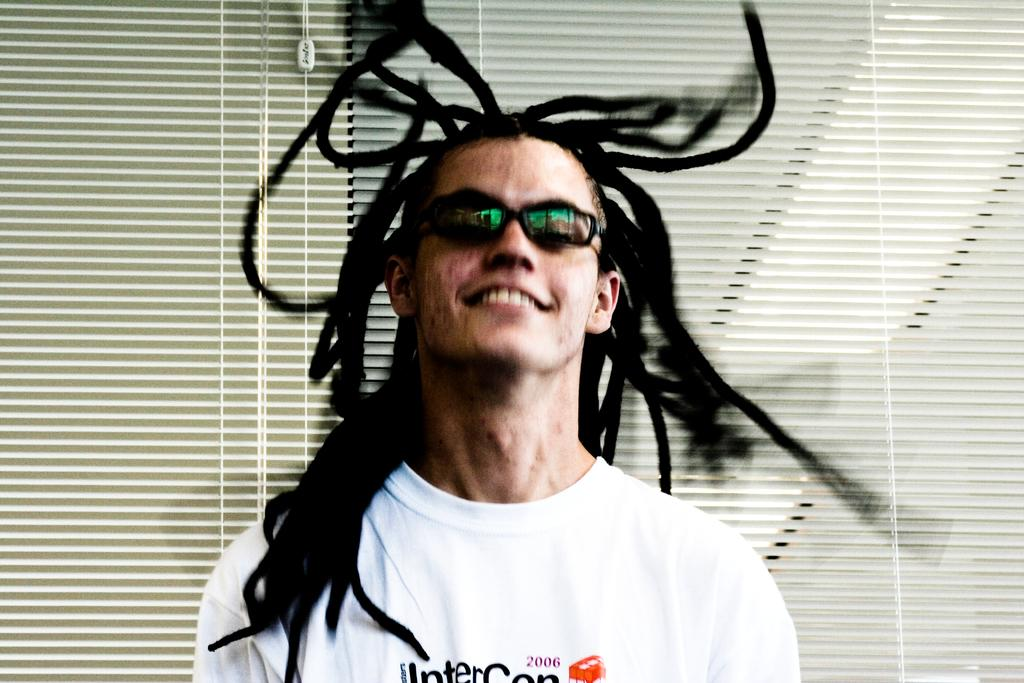Who is present in the image? There is a man in the image. What is the man doing in the image? The man is smiling in the image. What can be seen in the background of the image? There are blinds in the background of the image. What song is the man singing in the image? There is no indication in the image that the man is singing a song, so it cannot be determined from the picture. 